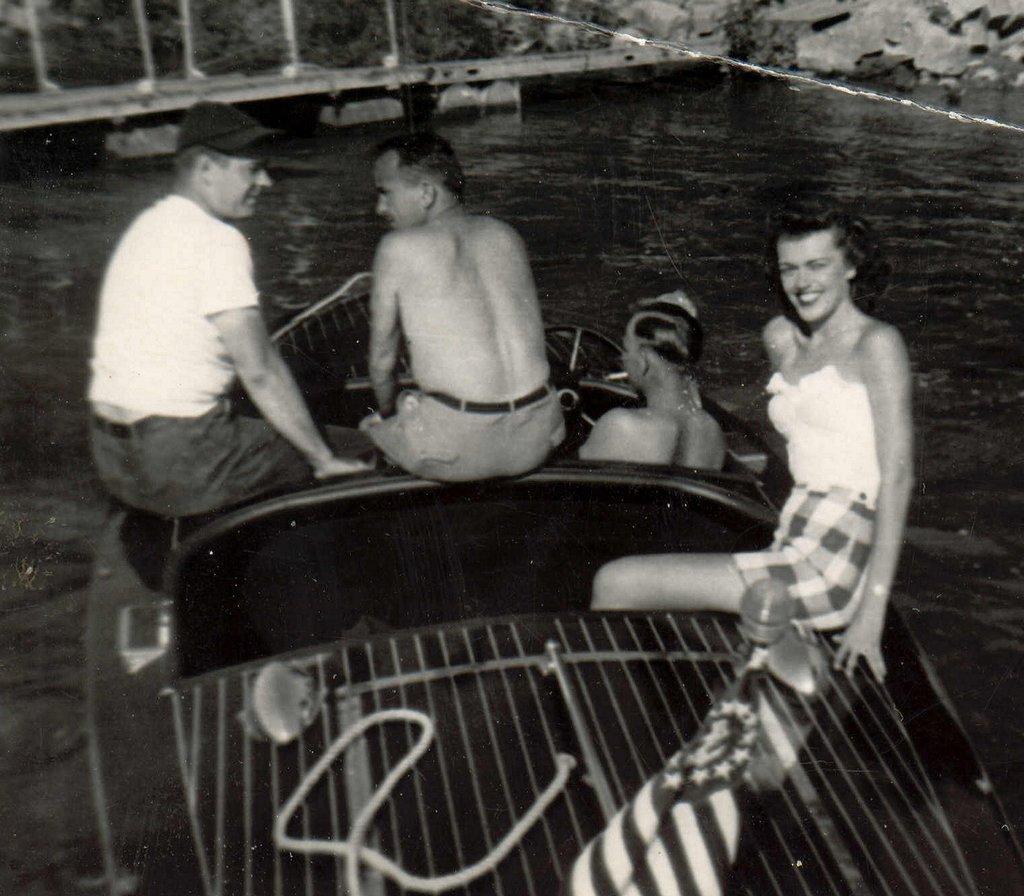Could you give a brief overview of what you see in this image? This is a black and white pic. There are four persons in the boat on the water and there is a flag and a rope on the boat. In the background we can see trees,stones,poles and a bridge. 